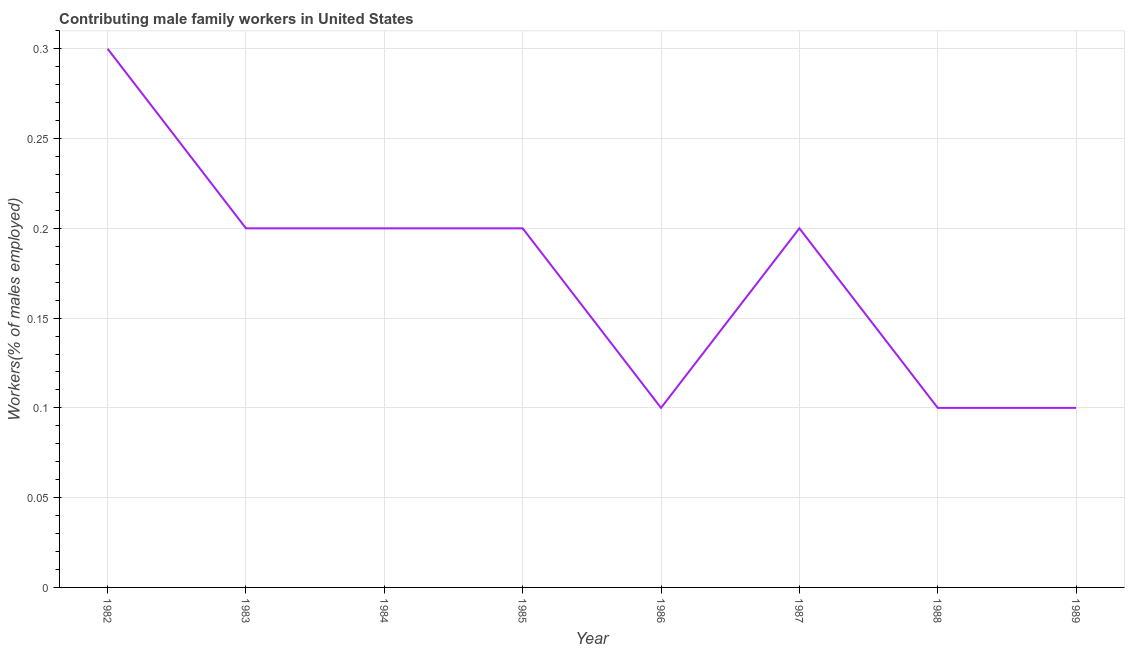What is the contributing male family workers in 1983?
Your answer should be compact. 0.2. Across all years, what is the maximum contributing male family workers?
Ensure brevity in your answer.  0.3. Across all years, what is the minimum contributing male family workers?
Your answer should be very brief. 0.1. In which year was the contributing male family workers maximum?
Make the answer very short. 1982. In which year was the contributing male family workers minimum?
Give a very brief answer. 1986. What is the sum of the contributing male family workers?
Your answer should be compact. 1.4. What is the difference between the contributing male family workers in 1983 and 1984?
Make the answer very short. 0. What is the average contributing male family workers per year?
Your response must be concise. 0.18. What is the median contributing male family workers?
Provide a succinct answer. 0.2. In how many years, is the contributing male family workers greater than 0.09 %?
Keep it short and to the point. 8. What is the ratio of the contributing male family workers in 1982 to that in 1983?
Offer a very short reply. 1.5. Is the contributing male family workers in 1982 less than that in 1988?
Your answer should be compact. No. What is the difference between the highest and the second highest contributing male family workers?
Offer a terse response. 0.1. What is the difference between the highest and the lowest contributing male family workers?
Provide a short and direct response. 0.2. In how many years, is the contributing male family workers greater than the average contributing male family workers taken over all years?
Offer a very short reply. 5. Does the contributing male family workers monotonically increase over the years?
Offer a very short reply. No. What is the title of the graph?
Ensure brevity in your answer.  Contributing male family workers in United States. What is the label or title of the X-axis?
Your response must be concise. Year. What is the label or title of the Y-axis?
Make the answer very short. Workers(% of males employed). What is the Workers(% of males employed) in 1982?
Make the answer very short. 0.3. What is the Workers(% of males employed) in 1983?
Ensure brevity in your answer.  0.2. What is the Workers(% of males employed) in 1984?
Provide a succinct answer. 0.2. What is the Workers(% of males employed) of 1985?
Provide a short and direct response. 0.2. What is the Workers(% of males employed) of 1986?
Provide a short and direct response. 0.1. What is the Workers(% of males employed) of 1987?
Provide a succinct answer. 0.2. What is the Workers(% of males employed) in 1988?
Ensure brevity in your answer.  0.1. What is the Workers(% of males employed) of 1989?
Provide a succinct answer. 0.1. What is the difference between the Workers(% of males employed) in 1982 and 1983?
Make the answer very short. 0.1. What is the difference between the Workers(% of males employed) in 1982 and 1984?
Provide a succinct answer. 0.1. What is the difference between the Workers(% of males employed) in 1982 and 1985?
Provide a succinct answer. 0.1. What is the difference between the Workers(% of males employed) in 1982 and 1986?
Provide a succinct answer. 0.2. What is the difference between the Workers(% of males employed) in 1982 and 1987?
Your response must be concise. 0.1. What is the difference between the Workers(% of males employed) in 1982 and 1988?
Offer a very short reply. 0.2. What is the difference between the Workers(% of males employed) in 1982 and 1989?
Your answer should be very brief. 0.2. What is the difference between the Workers(% of males employed) in 1983 and 1987?
Your answer should be very brief. 0. What is the difference between the Workers(% of males employed) in 1984 and 1989?
Give a very brief answer. 0.1. What is the difference between the Workers(% of males employed) in 1986 and 1989?
Your answer should be very brief. 0. What is the difference between the Workers(% of males employed) in 1987 and 1988?
Your answer should be compact. 0.1. What is the difference between the Workers(% of males employed) in 1987 and 1989?
Keep it short and to the point. 0.1. What is the ratio of the Workers(% of males employed) in 1982 to that in 1984?
Offer a very short reply. 1.5. What is the ratio of the Workers(% of males employed) in 1982 to that in 1985?
Keep it short and to the point. 1.5. What is the ratio of the Workers(% of males employed) in 1982 to that in 1986?
Offer a terse response. 3. What is the ratio of the Workers(% of males employed) in 1983 to that in 1986?
Provide a succinct answer. 2. What is the ratio of the Workers(% of males employed) in 1983 to that in 1988?
Your answer should be very brief. 2. What is the ratio of the Workers(% of males employed) in 1984 to that in 1986?
Provide a short and direct response. 2. What is the ratio of the Workers(% of males employed) in 1984 to that in 1987?
Make the answer very short. 1. What is the ratio of the Workers(% of males employed) in 1984 to that in 1988?
Your answer should be very brief. 2. What is the ratio of the Workers(% of males employed) in 1985 to that in 1987?
Offer a very short reply. 1. What is the ratio of the Workers(% of males employed) in 1985 to that in 1988?
Your answer should be very brief. 2. What is the ratio of the Workers(% of males employed) in 1986 to that in 1987?
Make the answer very short. 0.5. What is the ratio of the Workers(% of males employed) in 1986 to that in 1988?
Provide a short and direct response. 1. What is the ratio of the Workers(% of males employed) in 1987 to that in 1989?
Keep it short and to the point. 2. 